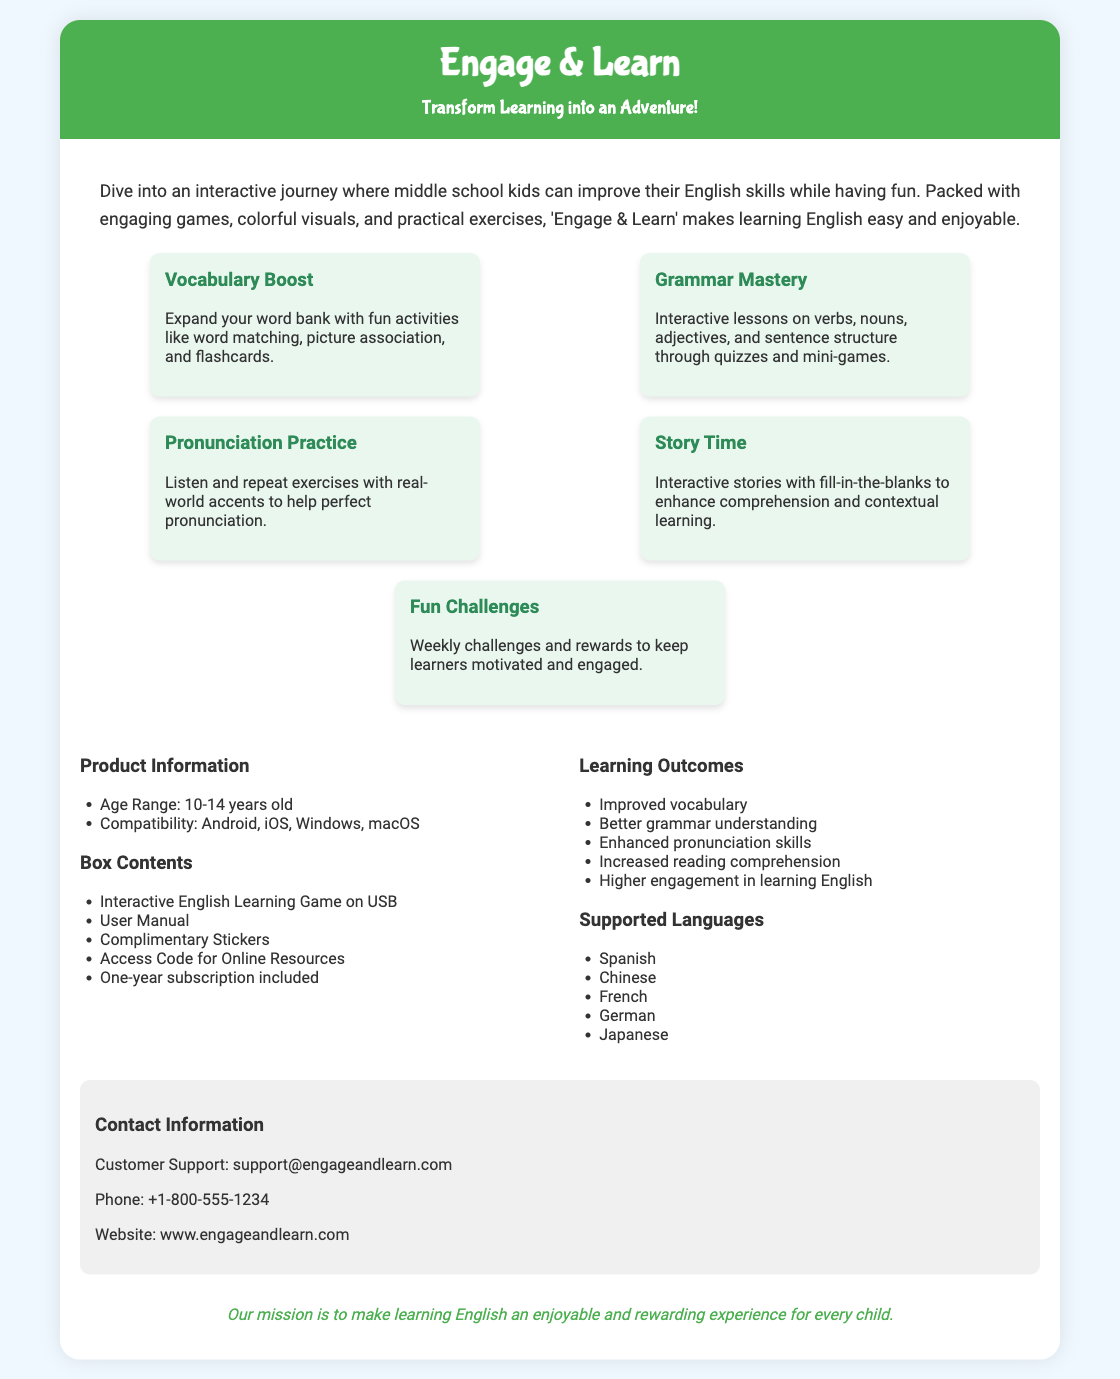what is the name of the product? The product is named "Engage & Learn".
Answer: Engage & Learn what is the age range for the game? The age range is specifically mentioned in the product information section.
Answer: 10-14 years old how many features are listed in the document? The document lists five distinct features under the features section.
Answer: 5 what activities are included in the vocabulary boost feature? The vocabulary boost feature specifies types of activities included.
Answer: word matching, picture association, and flashcards what types of devices can the game be used on? Device compatibility is provided in the product information section of the document.
Answer: Android, iOS, Windows, macOS what is included in the box contents? The box contents section lists items included with the product.
Answer: Interactive English Learning Game on USB, User Manual, Complimentary Stickers, Access Code for Online Resources, One-year subscription what is the main promise of the brand? The brand promise is stated at the end of the document.
Answer: enjoyable and rewarding experience for every child which languages are supported by the game? The supported languages are listed in the supported languages section.
Answer: Spanish, Chinese, French, German, Japanese 